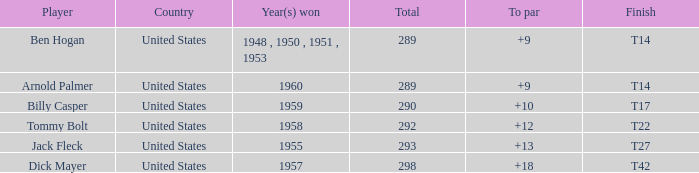What is the player's name, when the year(s) won is 1955? Jack Fleck. 